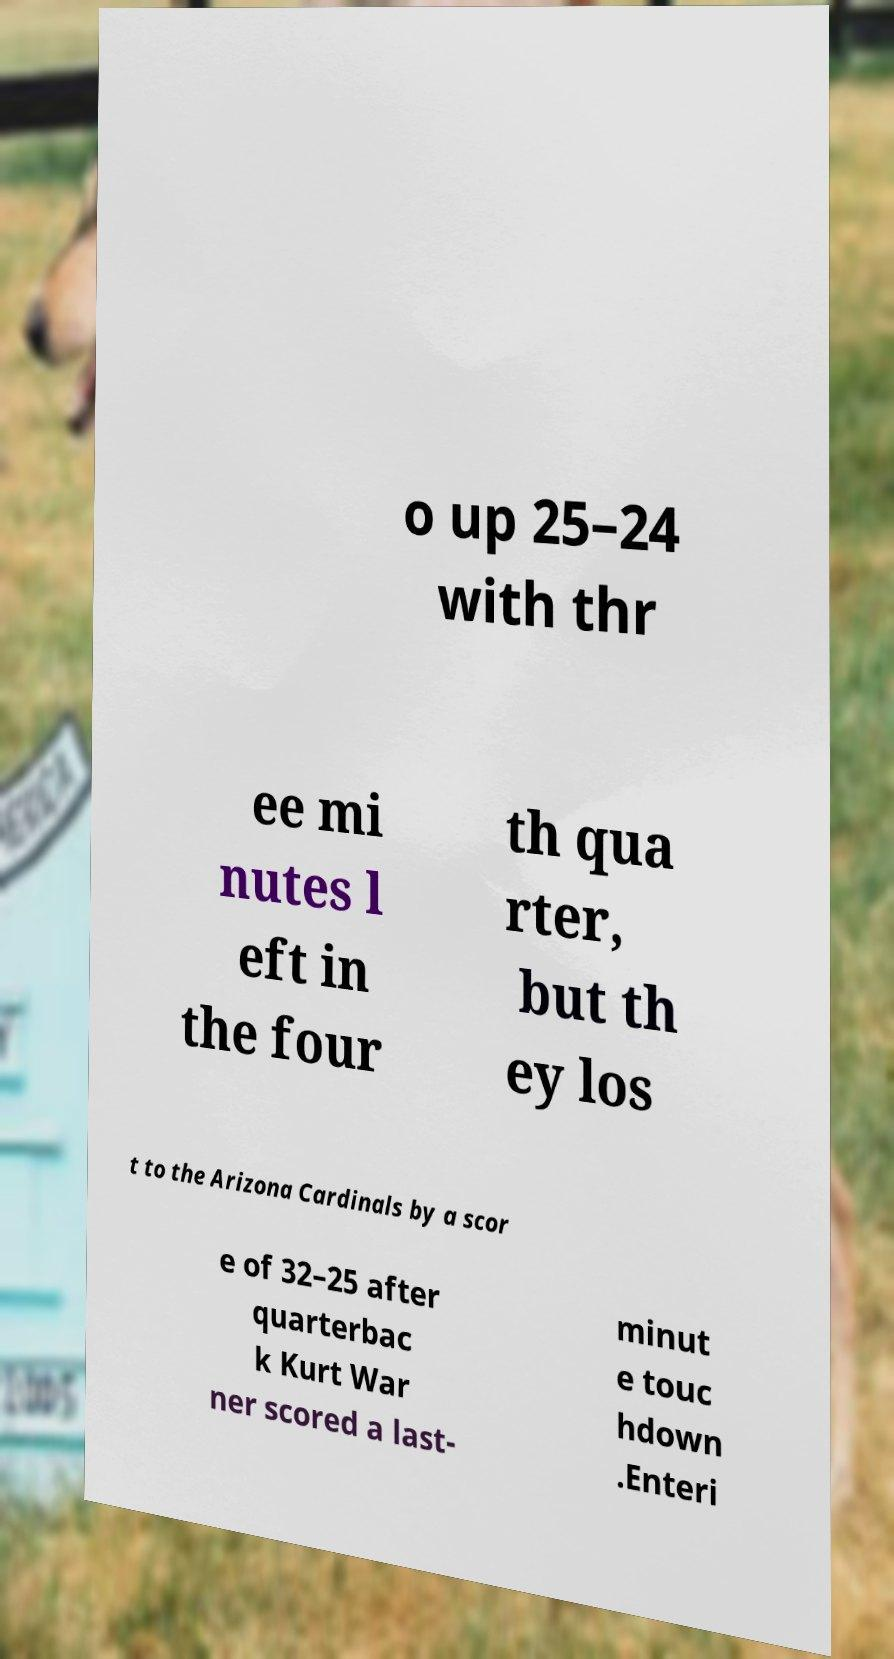There's text embedded in this image that I need extracted. Can you transcribe it verbatim? o up 25–24 with thr ee mi nutes l eft in the four th qua rter, but th ey los t to the Arizona Cardinals by a scor e of 32–25 after quarterbac k Kurt War ner scored a last- minut e touc hdown .Enteri 